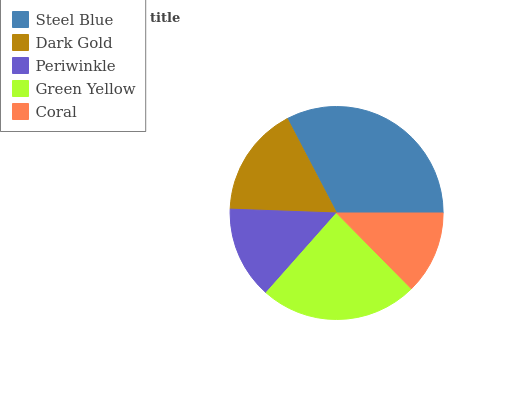Is Coral the minimum?
Answer yes or no. Yes. Is Steel Blue the maximum?
Answer yes or no. Yes. Is Dark Gold the minimum?
Answer yes or no. No. Is Dark Gold the maximum?
Answer yes or no. No. Is Steel Blue greater than Dark Gold?
Answer yes or no. Yes. Is Dark Gold less than Steel Blue?
Answer yes or no. Yes. Is Dark Gold greater than Steel Blue?
Answer yes or no. No. Is Steel Blue less than Dark Gold?
Answer yes or no. No. Is Dark Gold the high median?
Answer yes or no. Yes. Is Dark Gold the low median?
Answer yes or no. Yes. Is Coral the high median?
Answer yes or no. No. Is Coral the low median?
Answer yes or no. No. 